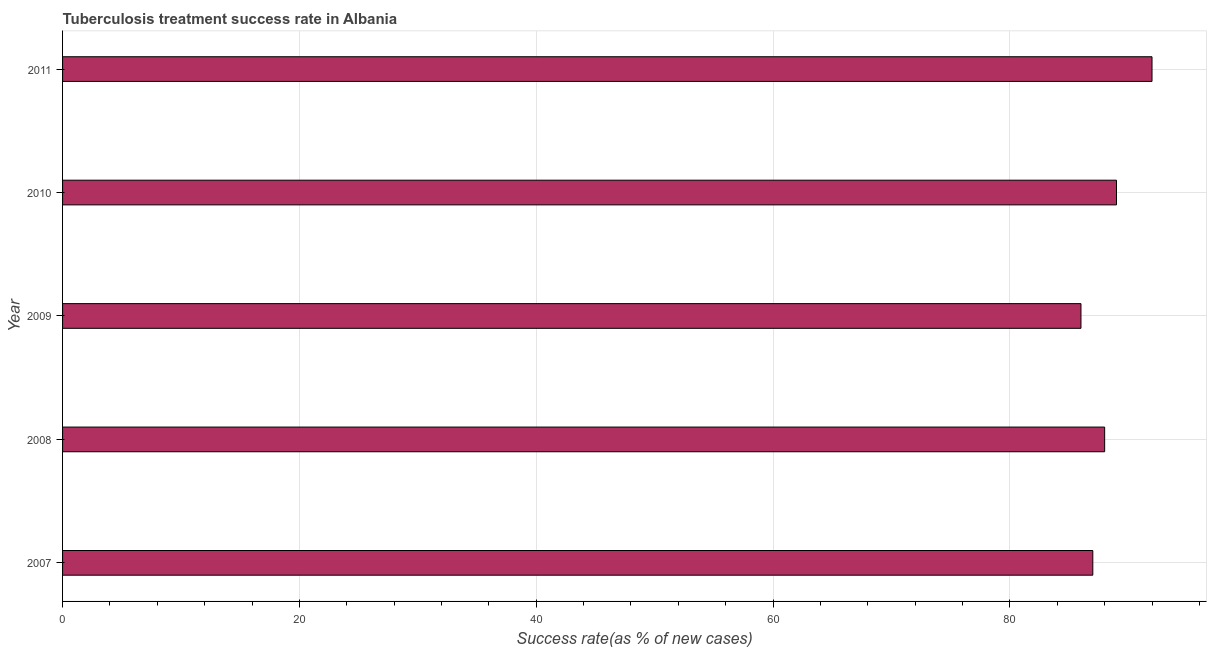Does the graph contain any zero values?
Give a very brief answer. No. What is the title of the graph?
Provide a succinct answer. Tuberculosis treatment success rate in Albania. What is the label or title of the X-axis?
Give a very brief answer. Success rate(as % of new cases). What is the label or title of the Y-axis?
Offer a terse response. Year. What is the tuberculosis treatment success rate in 2008?
Offer a very short reply. 88. Across all years, what is the maximum tuberculosis treatment success rate?
Give a very brief answer. 92. Across all years, what is the minimum tuberculosis treatment success rate?
Offer a terse response. 86. In which year was the tuberculosis treatment success rate maximum?
Provide a succinct answer. 2011. In which year was the tuberculosis treatment success rate minimum?
Offer a terse response. 2009. What is the sum of the tuberculosis treatment success rate?
Give a very brief answer. 442. What is the median tuberculosis treatment success rate?
Offer a terse response. 88. In how many years, is the tuberculosis treatment success rate greater than 44 %?
Your response must be concise. 5. Is the difference between the tuberculosis treatment success rate in 2010 and 2011 greater than the difference between any two years?
Give a very brief answer. No. What is the difference between the highest and the second highest tuberculosis treatment success rate?
Your answer should be compact. 3. Is the sum of the tuberculosis treatment success rate in 2009 and 2010 greater than the maximum tuberculosis treatment success rate across all years?
Offer a very short reply. Yes. In how many years, is the tuberculosis treatment success rate greater than the average tuberculosis treatment success rate taken over all years?
Provide a short and direct response. 2. What is the difference between two consecutive major ticks on the X-axis?
Provide a short and direct response. 20. Are the values on the major ticks of X-axis written in scientific E-notation?
Offer a terse response. No. What is the Success rate(as % of new cases) in 2010?
Your response must be concise. 89. What is the Success rate(as % of new cases) of 2011?
Your response must be concise. 92. What is the difference between the Success rate(as % of new cases) in 2007 and 2009?
Give a very brief answer. 1. What is the difference between the Success rate(as % of new cases) in 2007 and 2011?
Give a very brief answer. -5. What is the difference between the Success rate(as % of new cases) in 2008 and 2009?
Offer a terse response. 2. What is the difference between the Success rate(as % of new cases) in 2008 and 2010?
Keep it short and to the point. -1. What is the difference between the Success rate(as % of new cases) in 2008 and 2011?
Provide a succinct answer. -4. What is the difference between the Success rate(as % of new cases) in 2009 and 2010?
Your answer should be compact. -3. What is the difference between the Success rate(as % of new cases) in 2009 and 2011?
Your answer should be very brief. -6. What is the ratio of the Success rate(as % of new cases) in 2007 to that in 2009?
Offer a very short reply. 1.01. What is the ratio of the Success rate(as % of new cases) in 2007 to that in 2011?
Your response must be concise. 0.95. What is the ratio of the Success rate(as % of new cases) in 2008 to that in 2009?
Provide a succinct answer. 1.02. What is the ratio of the Success rate(as % of new cases) in 2008 to that in 2010?
Give a very brief answer. 0.99. What is the ratio of the Success rate(as % of new cases) in 2009 to that in 2010?
Provide a succinct answer. 0.97. What is the ratio of the Success rate(as % of new cases) in 2009 to that in 2011?
Give a very brief answer. 0.94. What is the ratio of the Success rate(as % of new cases) in 2010 to that in 2011?
Ensure brevity in your answer.  0.97. 